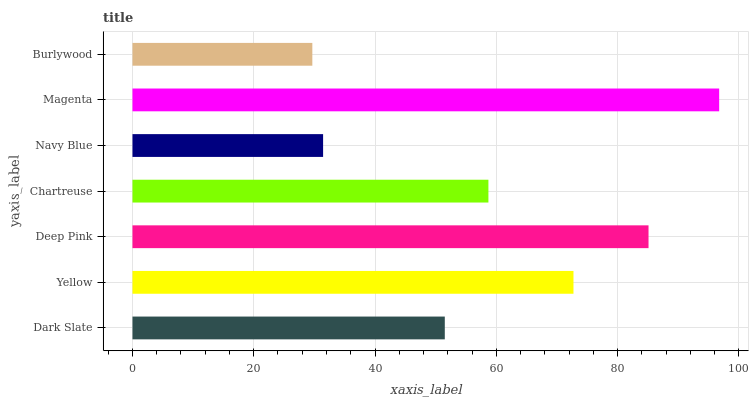Is Burlywood the minimum?
Answer yes or no. Yes. Is Magenta the maximum?
Answer yes or no. Yes. Is Yellow the minimum?
Answer yes or no. No. Is Yellow the maximum?
Answer yes or no. No. Is Yellow greater than Dark Slate?
Answer yes or no. Yes. Is Dark Slate less than Yellow?
Answer yes or no. Yes. Is Dark Slate greater than Yellow?
Answer yes or no. No. Is Yellow less than Dark Slate?
Answer yes or no. No. Is Chartreuse the high median?
Answer yes or no. Yes. Is Chartreuse the low median?
Answer yes or no. Yes. Is Dark Slate the high median?
Answer yes or no. No. Is Burlywood the low median?
Answer yes or no. No. 